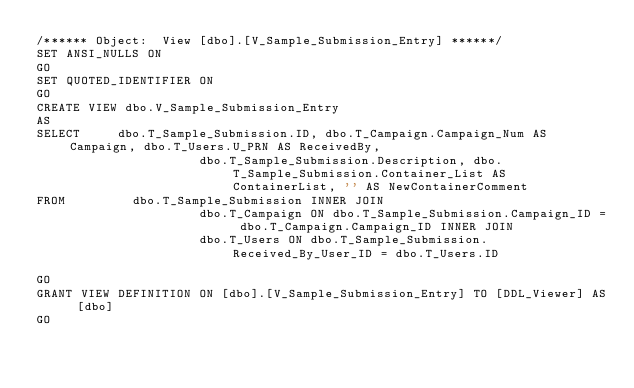<code> <loc_0><loc_0><loc_500><loc_500><_SQL_>/****** Object:  View [dbo].[V_Sample_Submission_Entry] ******/
SET ANSI_NULLS ON
GO
SET QUOTED_IDENTIFIER ON
GO
CREATE VIEW dbo.V_Sample_Submission_Entry
AS
SELECT     dbo.T_Sample_Submission.ID, dbo.T_Campaign.Campaign_Num AS Campaign, dbo.T_Users.U_PRN AS ReceivedBy, 
                      dbo.T_Sample_Submission.Description, dbo.T_Sample_Submission.Container_List AS ContainerList, '' AS NewContainerComment
FROM         dbo.T_Sample_Submission INNER JOIN
                      dbo.T_Campaign ON dbo.T_Sample_Submission.Campaign_ID = dbo.T_Campaign.Campaign_ID INNER JOIN
                      dbo.T_Users ON dbo.T_Sample_Submission.Received_By_User_ID = dbo.T_Users.ID

GO
GRANT VIEW DEFINITION ON [dbo].[V_Sample_Submission_Entry] TO [DDL_Viewer] AS [dbo]
GO
</code> 